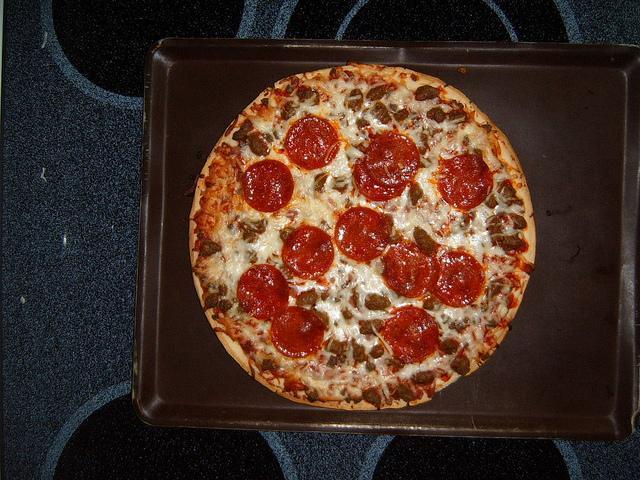How many people are wearing glasses?
Give a very brief answer. 0. 